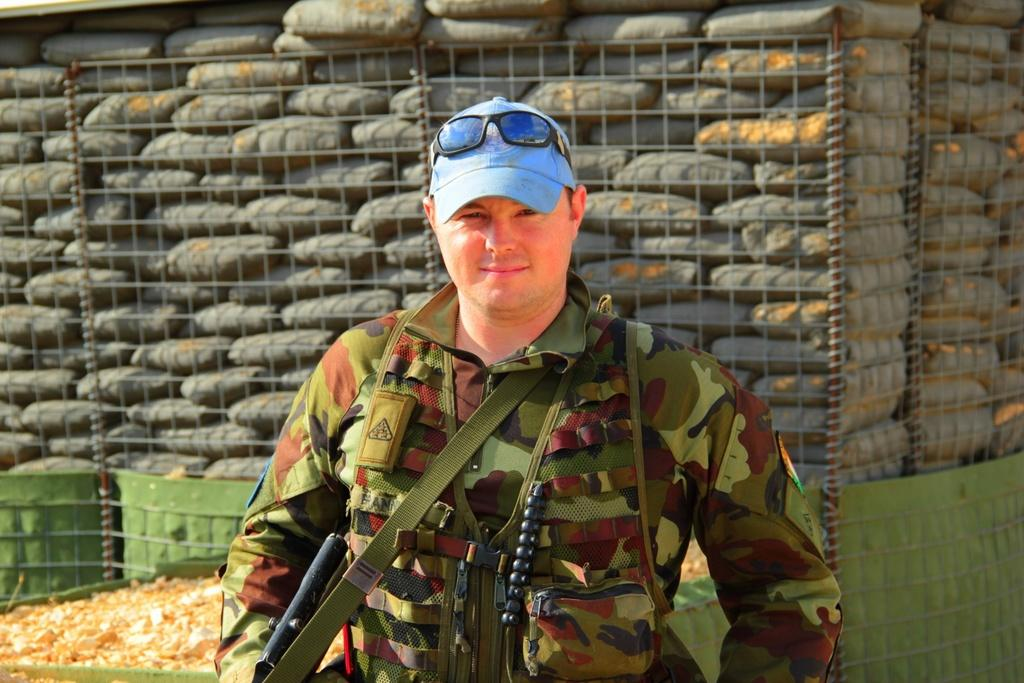What is the man in the image doing? The man is standing in the image and appears to be a soldier. What is the man's facial expression in the image? The man is smiling in the image. What object is the man holding in his hand? The man is holding a gun in his hand. What can be seen near the bags in the image? There is a fence around the bags in the image. What type of bird can be seen flying over the man's head in the image? There is no bird visible in the image; it only features a man, a gun, bags, and a fence. 